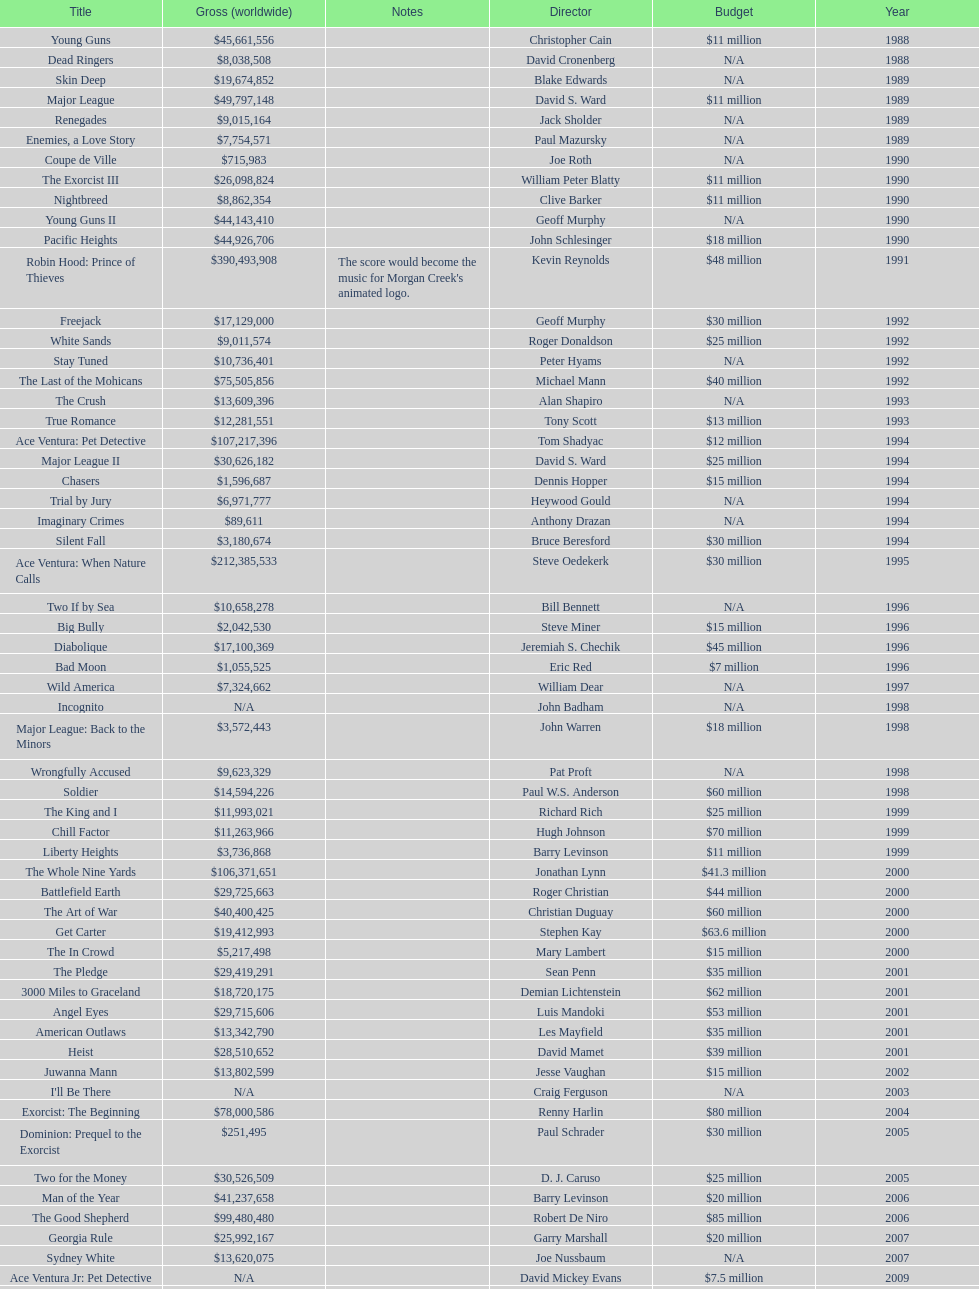Did true romance make more or less money than diabolique? Less. 